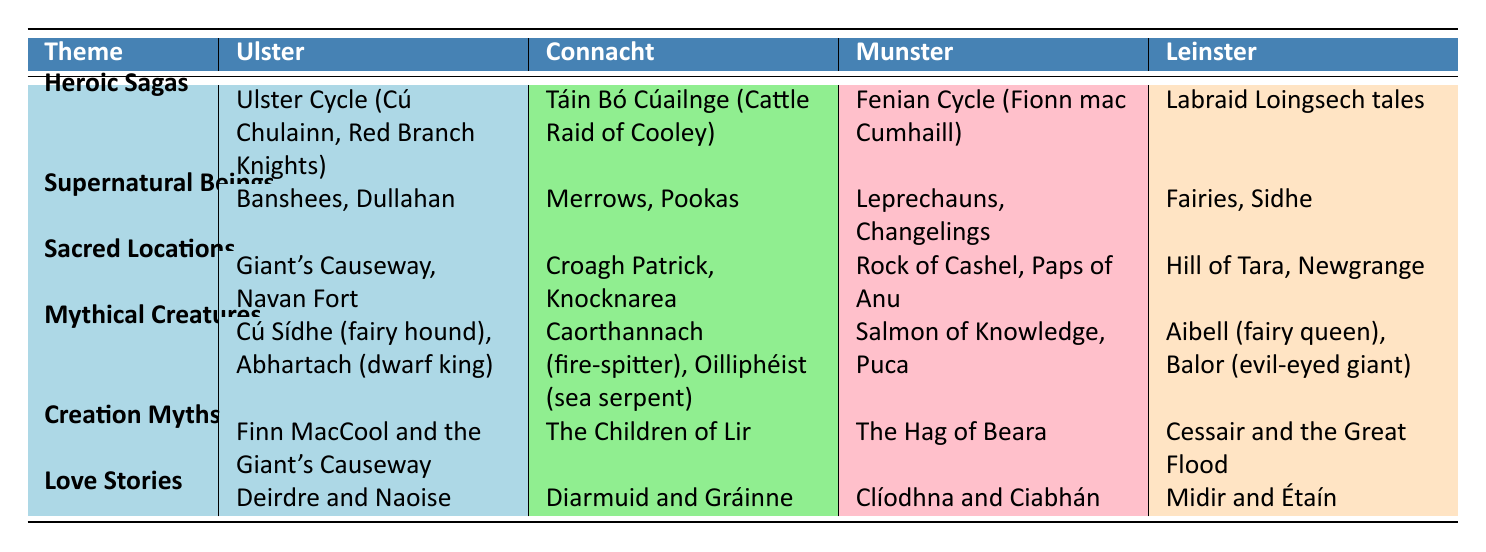What heroic saga is associated with Connacht? According to the table, the heroic saga from Connacht is "Táin Bó Cúailnge (Cattle Raid of Cooley)." This information is directly retrieved from the "Heroic Sagas" row and the "Connacht" column.
Answer: Táin Bó Cúailnge (Cattle Raid of Cooley) Which region features the Salmon of Knowledge in its mythical creatures? The table shows that the "Salmon of Knowledge" is listed under the "Mythical Creatures" section for Munster. This is a retrieval question as the answer can be found directly in the table.
Answer: Munster True or False: Banshees are considered sacred locations in Ulster. The table lists "Banshees" under the "Supernatural Beings" theme for Ulster, not under "Sacred Locations." Therefore, the statement is false.
Answer: False What is the unique supernatural being found in Munster? Referring to the "Supernatural Beings" theme in the table, Munster features "Leprechauns, Changelings." This information is in the specific row corresponding to supernatural beings for the Munster region.
Answer: Leprechauns, Changelings If we compare love stories, which regional story involves Midir? The row for "Love Stories" indicates that Midir's story, "Midir and Étaín," is linked to Leinster. This is a simple retrieval question based on direct information from the table.
Answer: Leinster Which region has the most mythical creatures listed? The rows compare different regions' mythical creatures. Ulster has "Cú Sídhe (fairy hound), Abhartach (dwarf king)," Connacht has "Caorthannach (fire-spitter), Oilliphéist (sea serpent)," Munster includes "Salmon of Knowledge, Puca," and Leinster lists "Aibell (fairy queen), Balor (evil-eyed giant)." Each region has two mythical creatures, indicating they are equal.
Answer: All regions have an equal number of mythical creatures What creation myth is associated with Connacht, and how does it differ from Ulster's? From the table, Connacht's creation myth is "The Children of Lir," while Ulster's is "Finn MacCool and the Giant's Causeway." This requires referencing both rows in the "Creation Myths" section. Therefore, the explanation includes identifying the different creation myths specific to each region.
Answer: The Children of Lir; differs from Finn MacCool and the Giant's Causeway Which region has the least mentioned sacred location? By inspecting the "Sacred Locations" column, all regions have two sacred locations mentioned: Ulster has "Giant's Causeway, Navan Fort," Connacht has "Croagh Patrick, Knocknarea," Munster includes "Rock of Cashel, Paps of Anu," and Leinster has "Hill of Tara, Newgrange." Thus, they all have the same count mentioned.
Answer: All regions mention two sacred locations 